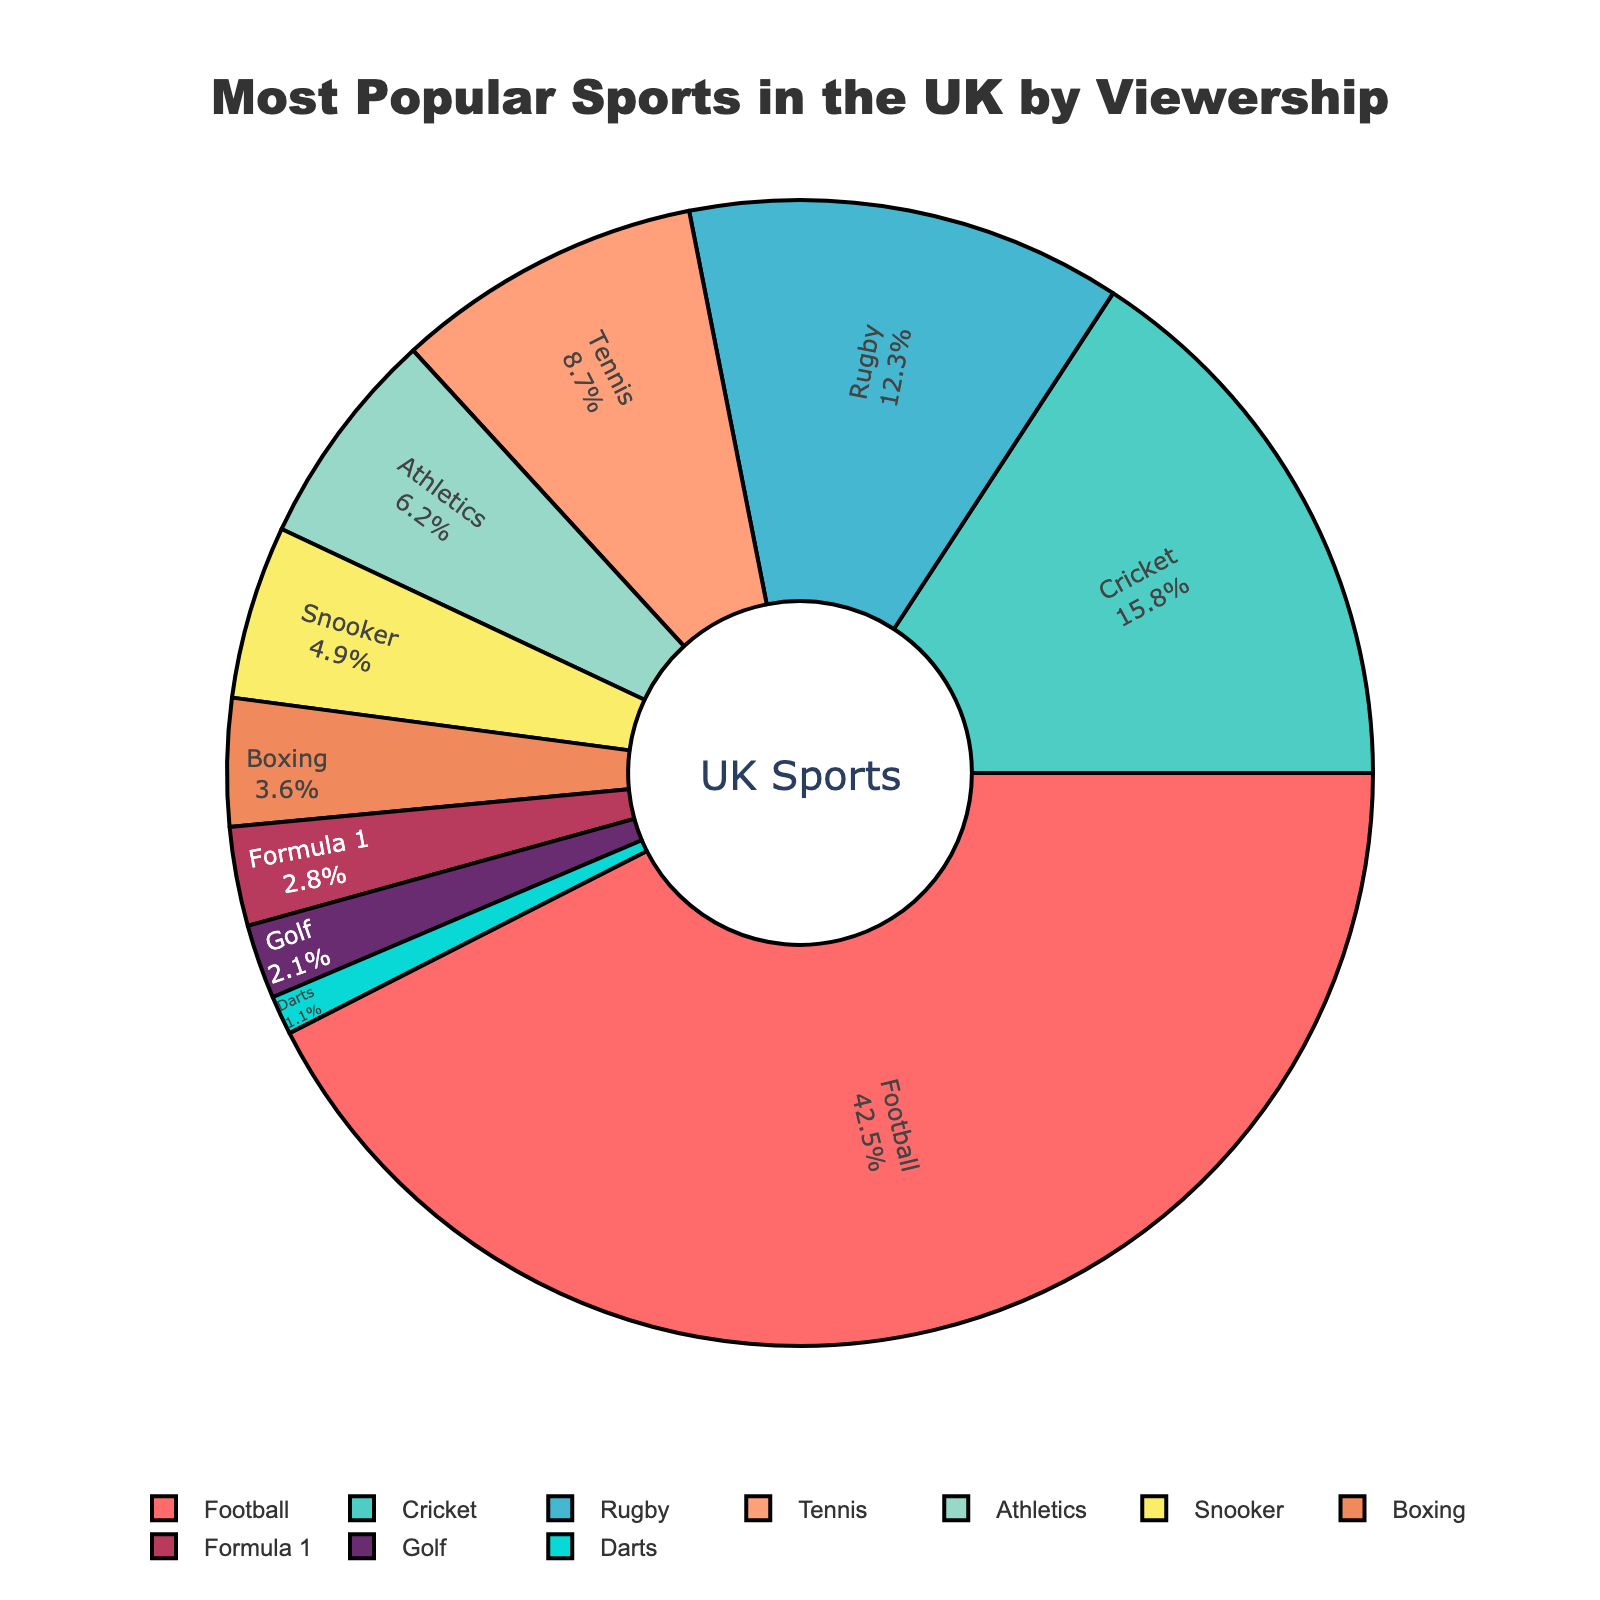Which sport has the highest viewership percentage? The sport with the highest viewership percentage is identified by finding the largest percentage value in the chart. Football has the highest viewership percentage of 42.5%.
Answer: Football Which sports have a viewership percentage less than 5%? To determine which sports have a viewership percentage of less than 5%, we look for sports with percentages below this threshold. Snooker, Boxing, Formula 1, Golf, and Darts have percentages less than 5%.
Answer: Snooker, Boxing, Formula 1, Golf, Darts How much higher is football's viewership percentage compared to cricket's? To find the difference in viewership percentage between football and cricket, we subtract cricket's percentage (15.8%) from football's percentage (42.5%). The difference is 42.5 - 15.8 = 26.7%.
Answer: 26.7% What is the combined viewership percentage of rugby and tennis? Combine the viewership percentages of rugby (12.3%) and tennis (8.7%) by adding them together. The sum is 12.3 + 8.7 = 21.0%.
Answer: 21.0% Which sport has a smaller viewership percentage: snooker or athletics? Compare the viewership percentages of snooker (4.9%) and athletics (6.2%). Since 4.9 is less than 6.2, snooker has a smaller viewership percentage than athletics.
Answer: Snooker What is the average viewership percentage of the top three most popular sports? To find the average viewership percentage of the top three sports (Football, Cricket, Rugby), sum their percentages (42.5 + 15.8 + 12.3) and divide by 3. This is (42.5 + 15.8 + 12.3) / 3 = 70.6 / 3 ≈ 23.53%.
Answer: 23.53% If you combine the percentages of the least three popular sports, what do you get? Combine the percentages of Formula 1 (2.8%), Golf (2.1%), and Darts (1.1%). The sum is 2.8 + 2.1 + 1.1 = 6.0%.
Answer: 6.0% How much greater is tennis's viewership percentage compared to boxing's? Subtract boxing's percentage (3.6%) from tennis's percentage (8.7%) to find the difference. The difference is 8.7 - 3.6 = 5.1%.
Answer: 5.1% Which sport is represented by the yellow section of the pie chart? Identify the sport represented by the yellow section by recognizing the color assignment. Athletics is represented by the yellow section.
Answer: Athletics What is the total percentage of sports with viewership percentages higher than 10%? Sum the percentages of sports with viewership percentages higher than 10%: Football (42.5%), Cricket (15.8%), and Rugby (12.3%). The total is 42.5 + 15.8 + 12.3 = 70.6%.
Answer: 70.6% 